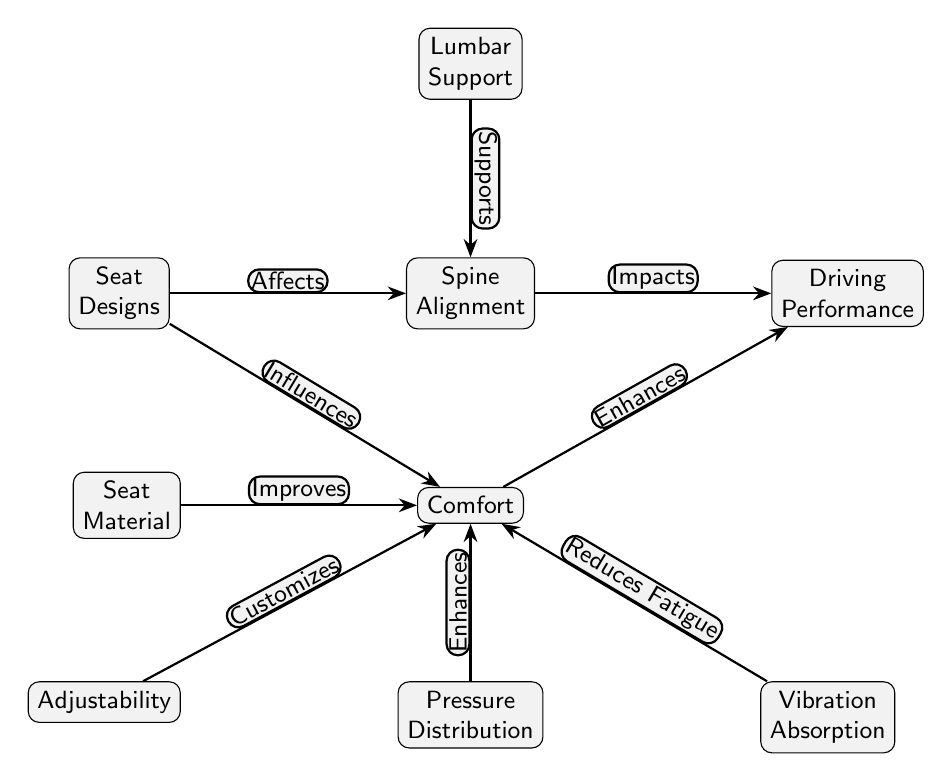What are the nodes connected to 'Seat Designs'? The diagram shows that 'Seat Designs' connects to 'Spine Alignment' and 'Comfort', which represent key areas influenced by different seat designs.
Answer: Spine Alignment, Comfort How does 'Lumbar Support' relate to 'Spine Alignment'? The diagram indicates a direct edge from 'Lumbar Support' to 'Spine Alignment', indicating that lumbar support has a supportive role in maintaining spine alignment.
Answer: Supports Which node enhances 'Comfort' along with 'Pressure Distribution'? The diagram shows that both 'Seat Material' and 'Vibration Absorption' are linked to 'Comfort' and contribute to enhancing it.
Answer: Seat Material, Vibration Absorption What effect does 'Comfort' have on 'Driving Performance'? According to the diagram, 'Comfort' directly enhances 'Driving Performance', showing a positive relationship where better comfort leads to improved performance.
Answer: Enhances What is the total number of nodes present in the diagram? By counting each unique node shown in the diagram, we find that there are eight distinct nodes representing various aspects related to seat design, spine alignment, and comfort.
Answer: Eight How do 'Adjustability' and 'Vibration Absorption' influence 'Comfort'? Both 'Adjustability' and 'Vibration Absorption' connect to 'Comfort' directly. Adjustability customizes comfort, while vibration absorption reduces fatigue, leading to a more comfortable driving experience.
Answer: Customizes, Reduces Fatigue What node is influenced by 'Spine Alignment' and directly impacts 'Driving Performance'? The diagram shows that 'Driving Performance' is directly impacted by 'Spine Alignment', indicating its importance in overall driving capabilities.
Answer: Impacts Which factor is most likely to improve 'Comfort'? The diagram illustrates several factors, but both 'Seat Material' and 'Pressure Distribution' directly enhance 'Comfort', emphasizing their significant roles.
Answer: Seat Material, Pressure Distribution Which two nodes are connected with a direct relationship to 'Comfort'? The nodes that have a direct relationship to 'Comfort' in the diagram are 'Seat Material' and 'Pressure Distribution', showing how they contribute to comfort levels.
Answer: Seat Material, Pressure Distribution 